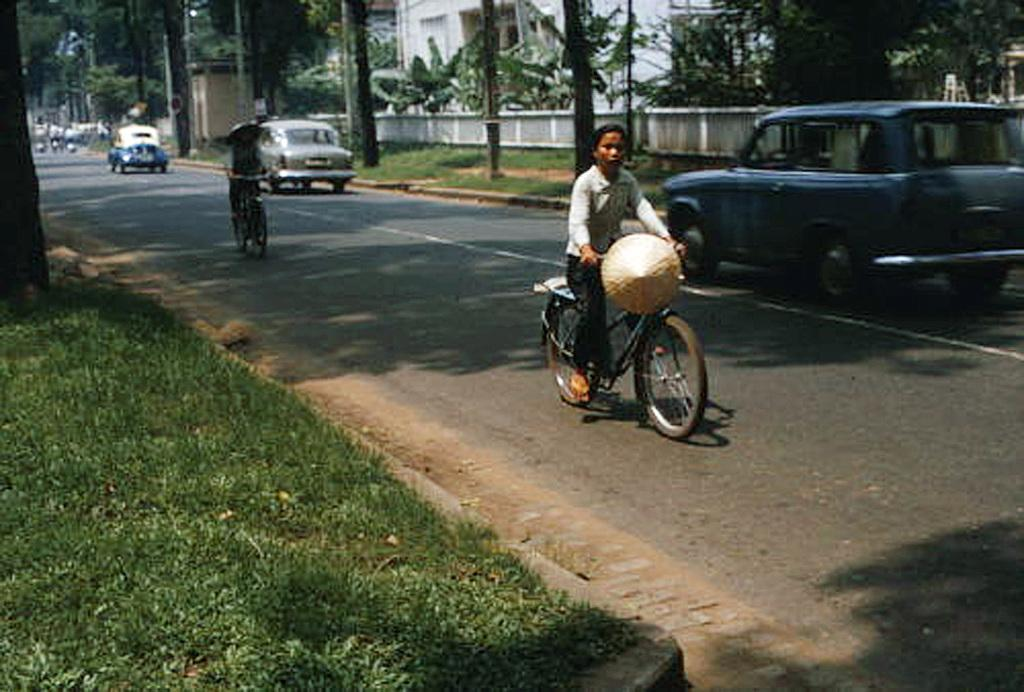What type of vehicles can be seen on the road in the image? There are cars on the road in the image. What are two people doing in the image? Two people are riding bicycles. What type of vegetation is on the left side of the image? There is grass on the left side of the image. What can be seen in the background of the image? There are trees and buildings in the background of the image. What color crayon is being used to draw on the trees in the image? There is no crayon present in the image, and the trees are not being drawn on. What type of shade is being provided by the pickle in the image? There is no pickle present in the image, so it cannot provide any shade. 